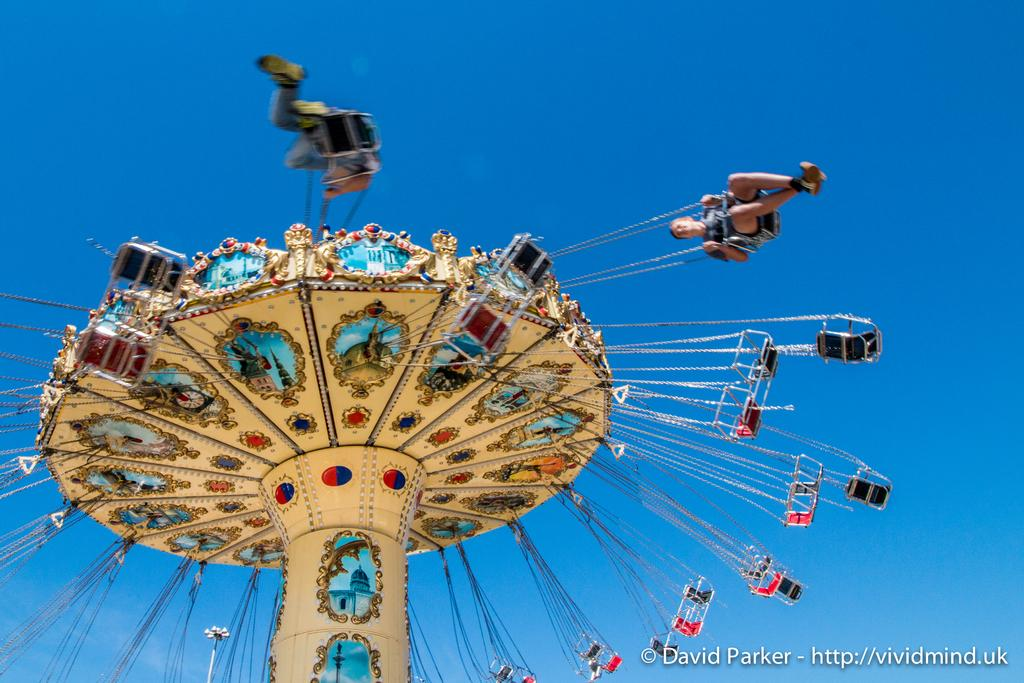What is the main subject of the image? There is a carousel in the image. Are there any people present in the image? Yes, there are people in the image. Can you describe any additional features of the image? There is a watermark at the right bottom of the image. How many fangs can be seen on the carousel in the image? There are no fangs present on the carousel in the image. What type of cap is being worn by the people in the image? There is no information about the people's clothing or accessories in the image, so we cannot determine if they are wearing caps. 